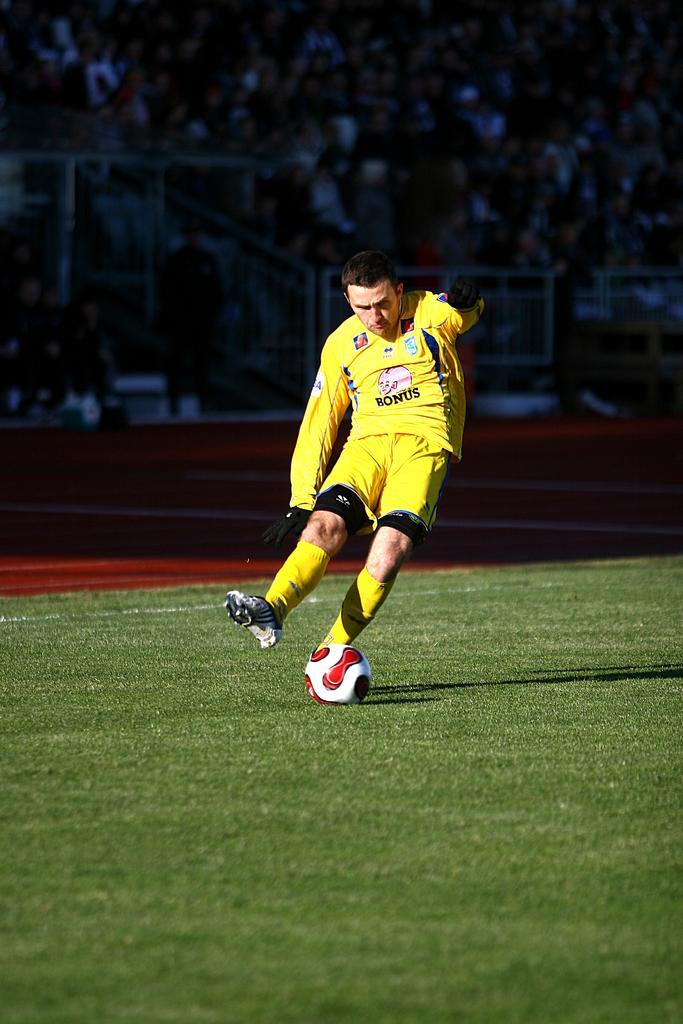In one or two sentences, can you explain what this image depicts? This person running and kicking ball. A far we can see audience are sitting. This is grass. 